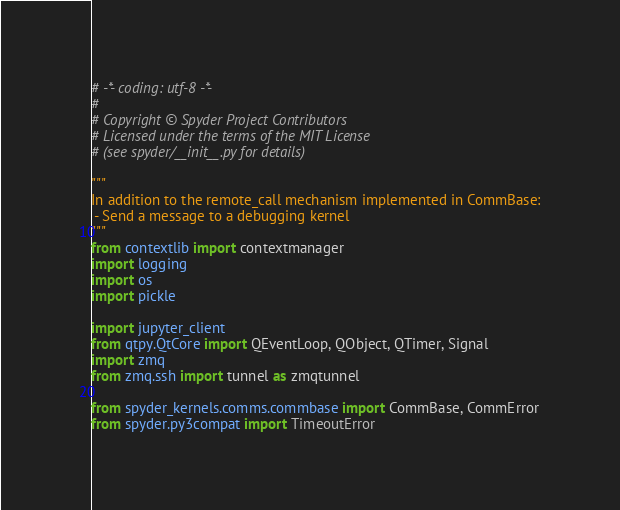<code> <loc_0><loc_0><loc_500><loc_500><_Python_># -*- coding: utf-8 -*-
#
# Copyright © Spyder Project Contributors
# Licensed under the terms of the MIT License
# (see spyder/__init__.py for details)

"""
In addition to the remote_call mechanism implemented in CommBase:
 - Send a message to a debugging kernel
"""
from contextlib import contextmanager
import logging
import os
import pickle

import jupyter_client
from qtpy.QtCore import QEventLoop, QObject, QTimer, Signal
import zmq
from zmq.ssh import tunnel as zmqtunnel

from spyder_kernels.comms.commbase import CommBase, CommError
from spyder.py3compat import TimeoutError</code> 